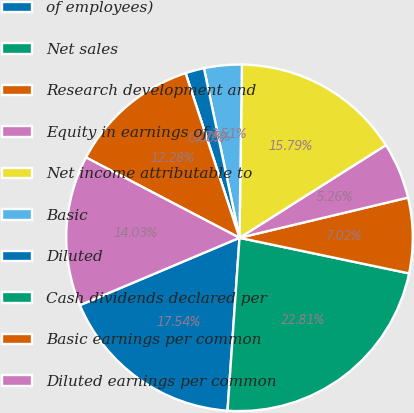<chart> <loc_0><loc_0><loc_500><loc_500><pie_chart><fcel>of employees)<fcel>Net sales<fcel>Research development and<fcel>Equity in earnings of<fcel>Net income attributable to<fcel>Basic<fcel>Diluted<fcel>Cash dividends declared per<fcel>Basic earnings per common<fcel>Diluted earnings per common<nl><fcel>17.54%<fcel>22.81%<fcel>7.02%<fcel>5.26%<fcel>15.79%<fcel>3.51%<fcel>1.75%<fcel>0.0%<fcel>12.28%<fcel>14.03%<nl></chart> 